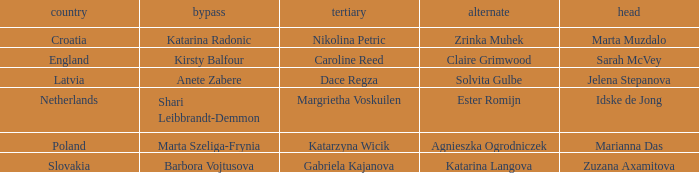What is the name of the third who has Barbora Vojtusova as Skip? Gabriela Kajanova. 